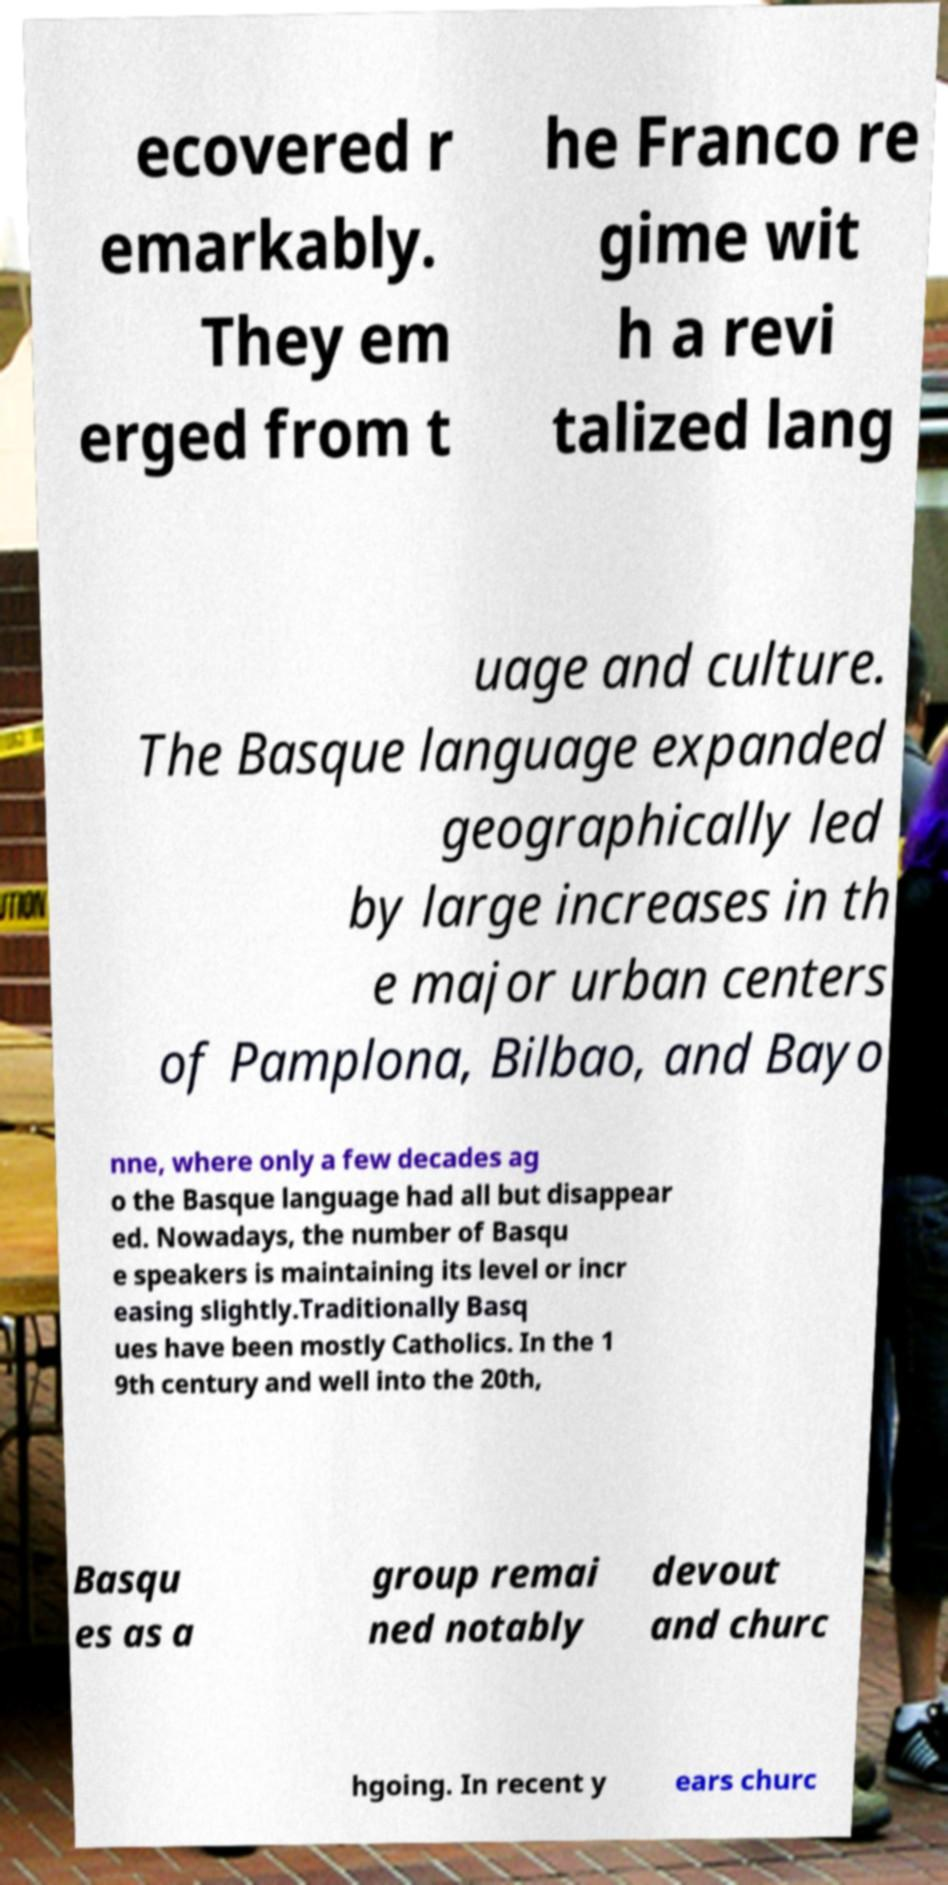Could you extract and type out the text from this image? ecovered r emarkably. They em erged from t he Franco re gime wit h a revi talized lang uage and culture. The Basque language expanded geographically led by large increases in th e major urban centers of Pamplona, Bilbao, and Bayo nne, where only a few decades ag o the Basque language had all but disappear ed. Nowadays, the number of Basqu e speakers is maintaining its level or incr easing slightly.Traditionally Basq ues have been mostly Catholics. In the 1 9th century and well into the 20th, Basqu es as a group remai ned notably devout and churc hgoing. In recent y ears churc 